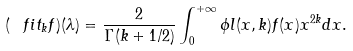Convert formula to latex. <formula><loc_0><loc_0><loc_500><loc_500>( \ f i t _ { k } f ) ( \lambda ) = \frac { 2 } { \Gamma ( k + 1 / 2 ) } \int _ { 0 } ^ { + \infty } \phi l ( x , k ) f ( x ) x ^ { 2 k } d x .</formula> 